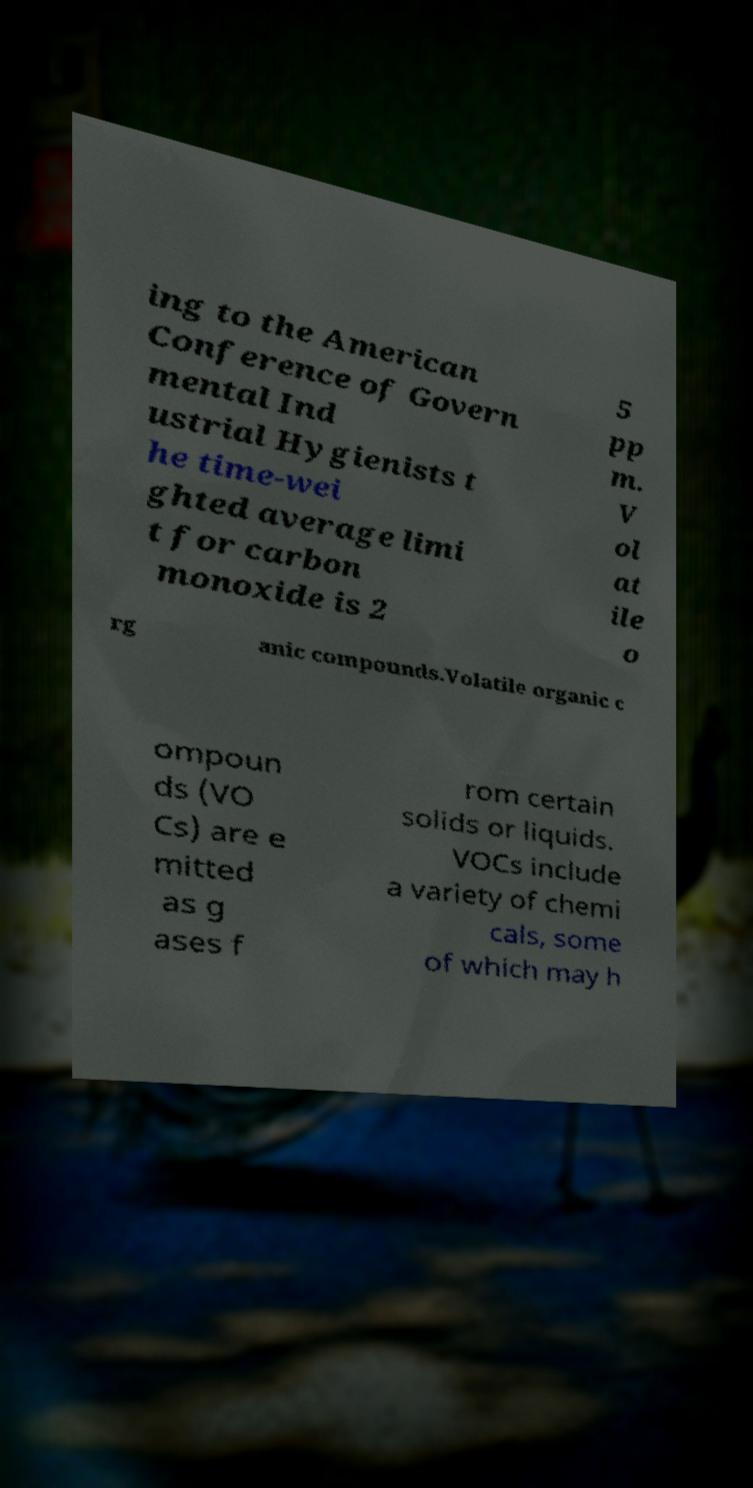Please identify and transcribe the text found in this image. ing to the American Conference of Govern mental Ind ustrial Hygienists t he time-wei ghted average limi t for carbon monoxide is 2 5 pp m. V ol at ile o rg anic compounds.Volatile organic c ompoun ds (VO Cs) are e mitted as g ases f rom certain solids or liquids. VOCs include a variety of chemi cals, some of which may h 